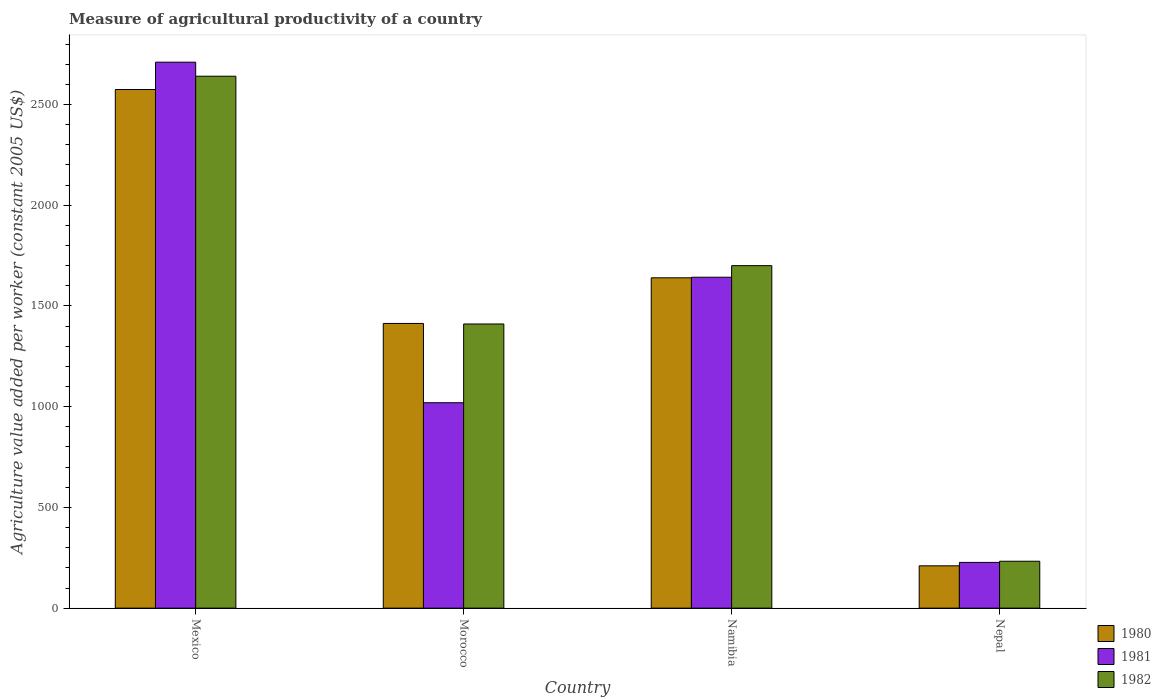How many different coloured bars are there?
Make the answer very short. 3. Are the number of bars per tick equal to the number of legend labels?
Make the answer very short. Yes. How many bars are there on the 2nd tick from the right?
Your answer should be compact. 3. What is the label of the 2nd group of bars from the left?
Your answer should be very brief. Morocco. What is the measure of agricultural productivity in 1981 in Nepal?
Give a very brief answer. 227.07. Across all countries, what is the maximum measure of agricultural productivity in 1981?
Your answer should be compact. 2709.94. Across all countries, what is the minimum measure of agricultural productivity in 1981?
Your response must be concise. 227.07. In which country was the measure of agricultural productivity in 1982 minimum?
Provide a succinct answer. Nepal. What is the total measure of agricultural productivity in 1981 in the graph?
Your answer should be compact. 5599.2. What is the difference between the measure of agricultural productivity in 1981 in Morocco and that in Namibia?
Your answer should be compact. -622.91. What is the difference between the measure of agricultural productivity in 1981 in Nepal and the measure of agricultural productivity in 1980 in Mexico?
Offer a very short reply. -2347.16. What is the average measure of agricultural productivity in 1980 per country?
Offer a terse response. 1459.28. What is the difference between the measure of agricultural productivity of/in 1982 and measure of agricultural productivity of/in 1981 in Morocco?
Your answer should be compact. 390.85. What is the ratio of the measure of agricultural productivity in 1980 in Mexico to that in Nepal?
Give a very brief answer. 12.25. What is the difference between the highest and the second highest measure of agricultural productivity in 1982?
Your response must be concise. 1229.78. What is the difference between the highest and the lowest measure of agricultural productivity in 1980?
Offer a very short reply. 2364.15. Are all the bars in the graph horizontal?
Give a very brief answer. No. What is the difference between two consecutive major ticks on the Y-axis?
Your response must be concise. 500. Does the graph contain grids?
Offer a very short reply. No. What is the title of the graph?
Make the answer very short. Measure of agricultural productivity of a country. Does "1973" appear as one of the legend labels in the graph?
Keep it short and to the point. No. What is the label or title of the X-axis?
Keep it short and to the point. Country. What is the label or title of the Y-axis?
Ensure brevity in your answer.  Agriculture value added per worker (constant 2005 US$). What is the Agriculture value added per worker (constant 2005 US$) in 1980 in Mexico?
Your answer should be very brief. 2574.24. What is the Agriculture value added per worker (constant 2005 US$) in 1981 in Mexico?
Provide a short and direct response. 2709.94. What is the Agriculture value added per worker (constant 2005 US$) of 1982 in Mexico?
Keep it short and to the point. 2640.27. What is the Agriculture value added per worker (constant 2005 US$) of 1980 in Morocco?
Ensure brevity in your answer.  1413.09. What is the Agriculture value added per worker (constant 2005 US$) of 1981 in Morocco?
Keep it short and to the point. 1019.64. What is the Agriculture value added per worker (constant 2005 US$) in 1982 in Morocco?
Offer a terse response. 1410.49. What is the Agriculture value added per worker (constant 2005 US$) of 1980 in Namibia?
Offer a very short reply. 1639.69. What is the Agriculture value added per worker (constant 2005 US$) in 1981 in Namibia?
Offer a very short reply. 1642.55. What is the Agriculture value added per worker (constant 2005 US$) of 1982 in Namibia?
Keep it short and to the point. 1699.99. What is the Agriculture value added per worker (constant 2005 US$) of 1980 in Nepal?
Keep it short and to the point. 210.09. What is the Agriculture value added per worker (constant 2005 US$) in 1981 in Nepal?
Your answer should be compact. 227.07. What is the Agriculture value added per worker (constant 2005 US$) in 1982 in Nepal?
Offer a very short reply. 232.83. Across all countries, what is the maximum Agriculture value added per worker (constant 2005 US$) of 1980?
Keep it short and to the point. 2574.24. Across all countries, what is the maximum Agriculture value added per worker (constant 2005 US$) in 1981?
Your answer should be compact. 2709.94. Across all countries, what is the maximum Agriculture value added per worker (constant 2005 US$) in 1982?
Ensure brevity in your answer.  2640.27. Across all countries, what is the minimum Agriculture value added per worker (constant 2005 US$) of 1980?
Offer a very short reply. 210.09. Across all countries, what is the minimum Agriculture value added per worker (constant 2005 US$) in 1981?
Offer a very short reply. 227.07. Across all countries, what is the minimum Agriculture value added per worker (constant 2005 US$) in 1982?
Ensure brevity in your answer.  232.83. What is the total Agriculture value added per worker (constant 2005 US$) of 1980 in the graph?
Your answer should be compact. 5837.11. What is the total Agriculture value added per worker (constant 2005 US$) in 1981 in the graph?
Your answer should be very brief. 5599.2. What is the total Agriculture value added per worker (constant 2005 US$) in 1982 in the graph?
Your answer should be very brief. 5983.57. What is the difference between the Agriculture value added per worker (constant 2005 US$) in 1980 in Mexico and that in Morocco?
Provide a short and direct response. 1161.14. What is the difference between the Agriculture value added per worker (constant 2005 US$) of 1981 in Mexico and that in Morocco?
Keep it short and to the point. 1690.3. What is the difference between the Agriculture value added per worker (constant 2005 US$) in 1982 in Mexico and that in Morocco?
Provide a succinct answer. 1229.78. What is the difference between the Agriculture value added per worker (constant 2005 US$) of 1980 in Mexico and that in Namibia?
Offer a very short reply. 934.54. What is the difference between the Agriculture value added per worker (constant 2005 US$) in 1981 in Mexico and that in Namibia?
Ensure brevity in your answer.  1067.39. What is the difference between the Agriculture value added per worker (constant 2005 US$) in 1982 in Mexico and that in Namibia?
Give a very brief answer. 940.28. What is the difference between the Agriculture value added per worker (constant 2005 US$) of 1980 in Mexico and that in Nepal?
Provide a succinct answer. 2364.15. What is the difference between the Agriculture value added per worker (constant 2005 US$) of 1981 in Mexico and that in Nepal?
Your answer should be compact. 2482.87. What is the difference between the Agriculture value added per worker (constant 2005 US$) in 1982 in Mexico and that in Nepal?
Your answer should be compact. 2407.43. What is the difference between the Agriculture value added per worker (constant 2005 US$) in 1980 in Morocco and that in Namibia?
Keep it short and to the point. -226.6. What is the difference between the Agriculture value added per worker (constant 2005 US$) in 1981 in Morocco and that in Namibia?
Your answer should be compact. -622.91. What is the difference between the Agriculture value added per worker (constant 2005 US$) of 1982 in Morocco and that in Namibia?
Your response must be concise. -289.5. What is the difference between the Agriculture value added per worker (constant 2005 US$) of 1980 in Morocco and that in Nepal?
Offer a very short reply. 1203. What is the difference between the Agriculture value added per worker (constant 2005 US$) of 1981 in Morocco and that in Nepal?
Offer a very short reply. 792.57. What is the difference between the Agriculture value added per worker (constant 2005 US$) of 1982 in Morocco and that in Nepal?
Offer a terse response. 1177.66. What is the difference between the Agriculture value added per worker (constant 2005 US$) in 1980 in Namibia and that in Nepal?
Your answer should be compact. 1429.6. What is the difference between the Agriculture value added per worker (constant 2005 US$) in 1981 in Namibia and that in Nepal?
Your response must be concise. 1415.48. What is the difference between the Agriculture value added per worker (constant 2005 US$) of 1982 in Namibia and that in Nepal?
Provide a succinct answer. 1467.16. What is the difference between the Agriculture value added per worker (constant 2005 US$) in 1980 in Mexico and the Agriculture value added per worker (constant 2005 US$) in 1981 in Morocco?
Provide a short and direct response. 1554.6. What is the difference between the Agriculture value added per worker (constant 2005 US$) in 1980 in Mexico and the Agriculture value added per worker (constant 2005 US$) in 1982 in Morocco?
Provide a short and direct response. 1163.75. What is the difference between the Agriculture value added per worker (constant 2005 US$) in 1981 in Mexico and the Agriculture value added per worker (constant 2005 US$) in 1982 in Morocco?
Your answer should be compact. 1299.45. What is the difference between the Agriculture value added per worker (constant 2005 US$) in 1980 in Mexico and the Agriculture value added per worker (constant 2005 US$) in 1981 in Namibia?
Offer a terse response. 931.68. What is the difference between the Agriculture value added per worker (constant 2005 US$) in 1980 in Mexico and the Agriculture value added per worker (constant 2005 US$) in 1982 in Namibia?
Provide a succinct answer. 874.25. What is the difference between the Agriculture value added per worker (constant 2005 US$) of 1981 in Mexico and the Agriculture value added per worker (constant 2005 US$) of 1982 in Namibia?
Offer a very short reply. 1009.95. What is the difference between the Agriculture value added per worker (constant 2005 US$) in 1980 in Mexico and the Agriculture value added per worker (constant 2005 US$) in 1981 in Nepal?
Provide a succinct answer. 2347.16. What is the difference between the Agriculture value added per worker (constant 2005 US$) of 1980 in Mexico and the Agriculture value added per worker (constant 2005 US$) of 1982 in Nepal?
Keep it short and to the point. 2341.4. What is the difference between the Agriculture value added per worker (constant 2005 US$) in 1981 in Mexico and the Agriculture value added per worker (constant 2005 US$) in 1982 in Nepal?
Ensure brevity in your answer.  2477.11. What is the difference between the Agriculture value added per worker (constant 2005 US$) of 1980 in Morocco and the Agriculture value added per worker (constant 2005 US$) of 1981 in Namibia?
Provide a succinct answer. -229.46. What is the difference between the Agriculture value added per worker (constant 2005 US$) in 1980 in Morocco and the Agriculture value added per worker (constant 2005 US$) in 1982 in Namibia?
Offer a terse response. -286.9. What is the difference between the Agriculture value added per worker (constant 2005 US$) of 1981 in Morocco and the Agriculture value added per worker (constant 2005 US$) of 1982 in Namibia?
Ensure brevity in your answer.  -680.35. What is the difference between the Agriculture value added per worker (constant 2005 US$) in 1980 in Morocco and the Agriculture value added per worker (constant 2005 US$) in 1981 in Nepal?
Your answer should be compact. 1186.02. What is the difference between the Agriculture value added per worker (constant 2005 US$) of 1980 in Morocco and the Agriculture value added per worker (constant 2005 US$) of 1982 in Nepal?
Provide a succinct answer. 1180.26. What is the difference between the Agriculture value added per worker (constant 2005 US$) of 1981 in Morocco and the Agriculture value added per worker (constant 2005 US$) of 1982 in Nepal?
Provide a short and direct response. 786.81. What is the difference between the Agriculture value added per worker (constant 2005 US$) in 1980 in Namibia and the Agriculture value added per worker (constant 2005 US$) in 1981 in Nepal?
Offer a very short reply. 1412.62. What is the difference between the Agriculture value added per worker (constant 2005 US$) in 1980 in Namibia and the Agriculture value added per worker (constant 2005 US$) in 1982 in Nepal?
Your answer should be compact. 1406.86. What is the difference between the Agriculture value added per worker (constant 2005 US$) in 1981 in Namibia and the Agriculture value added per worker (constant 2005 US$) in 1982 in Nepal?
Provide a succinct answer. 1409.72. What is the average Agriculture value added per worker (constant 2005 US$) in 1980 per country?
Offer a very short reply. 1459.28. What is the average Agriculture value added per worker (constant 2005 US$) of 1981 per country?
Your answer should be compact. 1399.8. What is the average Agriculture value added per worker (constant 2005 US$) in 1982 per country?
Make the answer very short. 1495.89. What is the difference between the Agriculture value added per worker (constant 2005 US$) in 1980 and Agriculture value added per worker (constant 2005 US$) in 1981 in Mexico?
Your answer should be very brief. -135.71. What is the difference between the Agriculture value added per worker (constant 2005 US$) of 1980 and Agriculture value added per worker (constant 2005 US$) of 1982 in Mexico?
Make the answer very short. -66.03. What is the difference between the Agriculture value added per worker (constant 2005 US$) of 1981 and Agriculture value added per worker (constant 2005 US$) of 1982 in Mexico?
Your response must be concise. 69.68. What is the difference between the Agriculture value added per worker (constant 2005 US$) of 1980 and Agriculture value added per worker (constant 2005 US$) of 1981 in Morocco?
Provide a short and direct response. 393.45. What is the difference between the Agriculture value added per worker (constant 2005 US$) of 1980 and Agriculture value added per worker (constant 2005 US$) of 1982 in Morocco?
Your response must be concise. 2.6. What is the difference between the Agriculture value added per worker (constant 2005 US$) of 1981 and Agriculture value added per worker (constant 2005 US$) of 1982 in Morocco?
Offer a terse response. -390.85. What is the difference between the Agriculture value added per worker (constant 2005 US$) in 1980 and Agriculture value added per worker (constant 2005 US$) in 1981 in Namibia?
Your answer should be compact. -2.86. What is the difference between the Agriculture value added per worker (constant 2005 US$) in 1980 and Agriculture value added per worker (constant 2005 US$) in 1982 in Namibia?
Give a very brief answer. -60.3. What is the difference between the Agriculture value added per worker (constant 2005 US$) of 1981 and Agriculture value added per worker (constant 2005 US$) of 1982 in Namibia?
Offer a very short reply. -57.44. What is the difference between the Agriculture value added per worker (constant 2005 US$) of 1980 and Agriculture value added per worker (constant 2005 US$) of 1981 in Nepal?
Make the answer very short. -16.98. What is the difference between the Agriculture value added per worker (constant 2005 US$) of 1980 and Agriculture value added per worker (constant 2005 US$) of 1982 in Nepal?
Ensure brevity in your answer.  -22.74. What is the difference between the Agriculture value added per worker (constant 2005 US$) in 1981 and Agriculture value added per worker (constant 2005 US$) in 1982 in Nepal?
Your response must be concise. -5.76. What is the ratio of the Agriculture value added per worker (constant 2005 US$) of 1980 in Mexico to that in Morocco?
Make the answer very short. 1.82. What is the ratio of the Agriculture value added per worker (constant 2005 US$) in 1981 in Mexico to that in Morocco?
Make the answer very short. 2.66. What is the ratio of the Agriculture value added per worker (constant 2005 US$) of 1982 in Mexico to that in Morocco?
Your answer should be very brief. 1.87. What is the ratio of the Agriculture value added per worker (constant 2005 US$) in 1980 in Mexico to that in Namibia?
Give a very brief answer. 1.57. What is the ratio of the Agriculture value added per worker (constant 2005 US$) in 1981 in Mexico to that in Namibia?
Your answer should be very brief. 1.65. What is the ratio of the Agriculture value added per worker (constant 2005 US$) in 1982 in Mexico to that in Namibia?
Your answer should be very brief. 1.55. What is the ratio of the Agriculture value added per worker (constant 2005 US$) in 1980 in Mexico to that in Nepal?
Keep it short and to the point. 12.25. What is the ratio of the Agriculture value added per worker (constant 2005 US$) in 1981 in Mexico to that in Nepal?
Provide a succinct answer. 11.93. What is the ratio of the Agriculture value added per worker (constant 2005 US$) in 1982 in Mexico to that in Nepal?
Offer a very short reply. 11.34. What is the ratio of the Agriculture value added per worker (constant 2005 US$) of 1980 in Morocco to that in Namibia?
Give a very brief answer. 0.86. What is the ratio of the Agriculture value added per worker (constant 2005 US$) in 1981 in Morocco to that in Namibia?
Ensure brevity in your answer.  0.62. What is the ratio of the Agriculture value added per worker (constant 2005 US$) of 1982 in Morocco to that in Namibia?
Make the answer very short. 0.83. What is the ratio of the Agriculture value added per worker (constant 2005 US$) in 1980 in Morocco to that in Nepal?
Make the answer very short. 6.73. What is the ratio of the Agriculture value added per worker (constant 2005 US$) of 1981 in Morocco to that in Nepal?
Offer a very short reply. 4.49. What is the ratio of the Agriculture value added per worker (constant 2005 US$) of 1982 in Morocco to that in Nepal?
Ensure brevity in your answer.  6.06. What is the ratio of the Agriculture value added per worker (constant 2005 US$) in 1980 in Namibia to that in Nepal?
Keep it short and to the point. 7.8. What is the ratio of the Agriculture value added per worker (constant 2005 US$) in 1981 in Namibia to that in Nepal?
Offer a very short reply. 7.23. What is the ratio of the Agriculture value added per worker (constant 2005 US$) of 1982 in Namibia to that in Nepal?
Make the answer very short. 7.3. What is the difference between the highest and the second highest Agriculture value added per worker (constant 2005 US$) of 1980?
Make the answer very short. 934.54. What is the difference between the highest and the second highest Agriculture value added per worker (constant 2005 US$) of 1981?
Give a very brief answer. 1067.39. What is the difference between the highest and the second highest Agriculture value added per worker (constant 2005 US$) of 1982?
Offer a very short reply. 940.28. What is the difference between the highest and the lowest Agriculture value added per worker (constant 2005 US$) of 1980?
Your answer should be very brief. 2364.15. What is the difference between the highest and the lowest Agriculture value added per worker (constant 2005 US$) in 1981?
Your response must be concise. 2482.87. What is the difference between the highest and the lowest Agriculture value added per worker (constant 2005 US$) in 1982?
Your answer should be compact. 2407.43. 